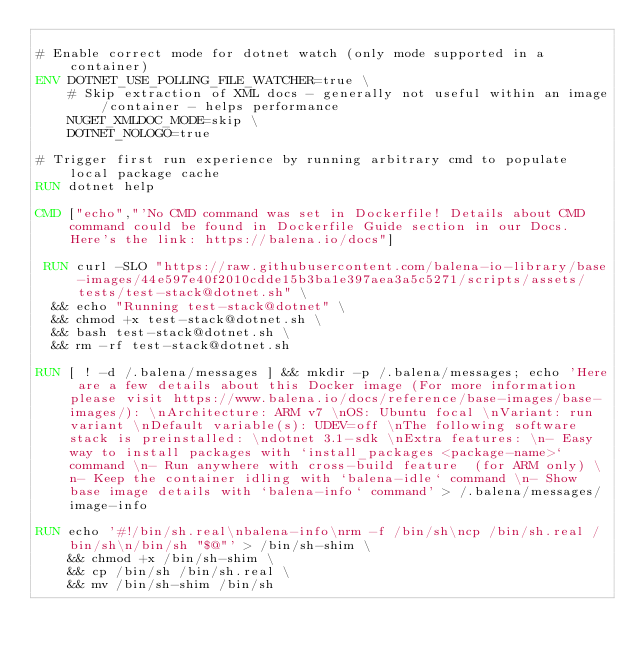<code> <loc_0><loc_0><loc_500><loc_500><_Dockerfile_>
# Enable correct mode for dotnet watch (only mode supported in a container)
ENV DOTNET_USE_POLLING_FILE_WATCHER=true \
    # Skip extraction of XML docs - generally not useful within an image/container - helps performance
    NUGET_XMLDOC_MODE=skip \
    DOTNET_NOLOGO=true

# Trigger first run experience by running arbitrary cmd to populate local package cache
RUN dotnet help

CMD ["echo","'No CMD command was set in Dockerfile! Details about CMD command could be found in Dockerfile Guide section in our Docs. Here's the link: https://balena.io/docs"]

 RUN curl -SLO "https://raw.githubusercontent.com/balena-io-library/base-images/44e597e40f2010cdde15b3ba1e397aea3a5c5271/scripts/assets/tests/test-stack@dotnet.sh" \
  && echo "Running test-stack@dotnet" \
  && chmod +x test-stack@dotnet.sh \
  && bash test-stack@dotnet.sh \
  && rm -rf test-stack@dotnet.sh 

RUN [ ! -d /.balena/messages ] && mkdir -p /.balena/messages; echo 'Here are a few details about this Docker image (For more information please visit https://www.balena.io/docs/reference/base-images/base-images/): \nArchitecture: ARM v7 \nOS: Ubuntu focal \nVariant: run variant \nDefault variable(s): UDEV=off \nThe following software stack is preinstalled: \ndotnet 3.1-sdk \nExtra features: \n- Easy way to install packages with `install_packages <package-name>` command \n- Run anywhere with cross-build feature  (for ARM only) \n- Keep the container idling with `balena-idle` command \n- Show base image details with `balena-info` command' > /.balena/messages/image-info

RUN echo '#!/bin/sh.real\nbalena-info\nrm -f /bin/sh\ncp /bin/sh.real /bin/sh\n/bin/sh "$@"' > /bin/sh-shim \
	&& chmod +x /bin/sh-shim \
	&& cp /bin/sh /bin/sh.real \
	&& mv /bin/sh-shim /bin/sh</code> 